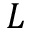Convert formula to latex. <formula><loc_0><loc_0><loc_500><loc_500>L</formula> 